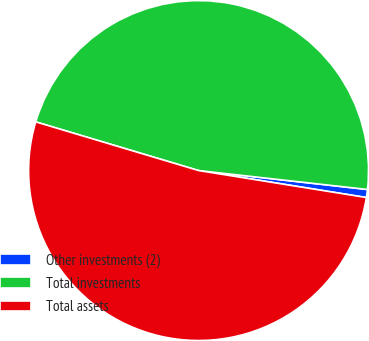Convert chart. <chart><loc_0><loc_0><loc_500><loc_500><pie_chart><fcel>Other investments (2)<fcel>Total investments<fcel>Total assets<nl><fcel>0.76%<fcel>47.16%<fcel>52.09%<nl></chart> 